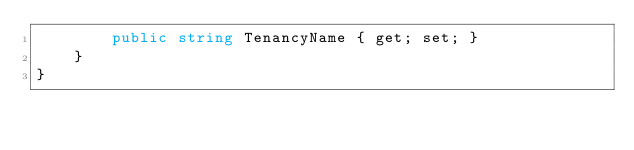<code> <loc_0><loc_0><loc_500><loc_500><_C#_>        public string TenancyName { get; set; }
    }
}
</code> 